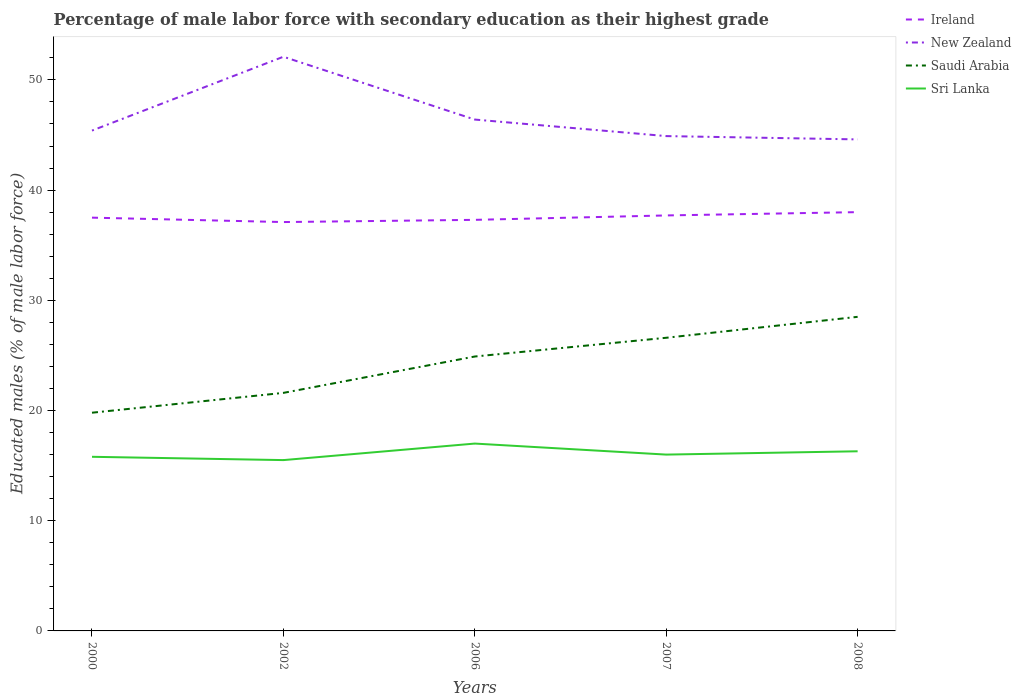How many different coloured lines are there?
Offer a very short reply. 4. Across all years, what is the maximum percentage of male labor force with secondary education in Saudi Arabia?
Give a very brief answer. 19.8. In which year was the percentage of male labor force with secondary education in Sri Lanka maximum?
Your response must be concise. 2002. What is the total percentage of male labor force with secondary education in Sri Lanka in the graph?
Give a very brief answer. 0.3. What is the difference between the highest and the second highest percentage of male labor force with secondary education in Ireland?
Offer a terse response. 0.9. How many lines are there?
Provide a short and direct response. 4. What is the difference between two consecutive major ticks on the Y-axis?
Ensure brevity in your answer.  10. Are the values on the major ticks of Y-axis written in scientific E-notation?
Provide a succinct answer. No. Does the graph contain any zero values?
Provide a short and direct response. No. What is the title of the graph?
Make the answer very short. Percentage of male labor force with secondary education as their highest grade. Does "Singapore" appear as one of the legend labels in the graph?
Ensure brevity in your answer.  No. What is the label or title of the Y-axis?
Provide a short and direct response. Educated males (% of male labor force). What is the Educated males (% of male labor force) in Ireland in 2000?
Make the answer very short. 37.5. What is the Educated males (% of male labor force) in New Zealand in 2000?
Your answer should be compact. 45.4. What is the Educated males (% of male labor force) in Saudi Arabia in 2000?
Provide a succinct answer. 19.8. What is the Educated males (% of male labor force) of Sri Lanka in 2000?
Your answer should be very brief. 15.8. What is the Educated males (% of male labor force) of Ireland in 2002?
Your response must be concise. 37.1. What is the Educated males (% of male labor force) of New Zealand in 2002?
Provide a succinct answer. 52.1. What is the Educated males (% of male labor force) in Saudi Arabia in 2002?
Ensure brevity in your answer.  21.6. What is the Educated males (% of male labor force) of Sri Lanka in 2002?
Your response must be concise. 15.5. What is the Educated males (% of male labor force) in Ireland in 2006?
Make the answer very short. 37.3. What is the Educated males (% of male labor force) in New Zealand in 2006?
Keep it short and to the point. 46.4. What is the Educated males (% of male labor force) in Saudi Arabia in 2006?
Offer a very short reply. 24.9. What is the Educated males (% of male labor force) of Ireland in 2007?
Provide a short and direct response. 37.7. What is the Educated males (% of male labor force) of New Zealand in 2007?
Offer a very short reply. 44.9. What is the Educated males (% of male labor force) of Saudi Arabia in 2007?
Give a very brief answer. 26.6. What is the Educated males (% of male labor force) in Sri Lanka in 2007?
Give a very brief answer. 16. What is the Educated males (% of male labor force) in New Zealand in 2008?
Keep it short and to the point. 44.6. What is the Educated males (% of male labor force) in Sri Lanka in 2008?
Keep it short and to the point. 16.3. Across all years, what is the maximum Educated males (% of male labor force) in New Zealand?
Ensure brevity in your answer.  52.1. Across all years, what is the maximum Educated males (% of male labor force) in Saudi Arabia?
Give a very brief answer. 28.5. Across all years, what is the maximum Educated males (% of male labor force) in Sri Lanka?
Your answer should be very brief. 17. Across all years, what is the minimum Educated males (% of male labor force) in Ireland?
Your answer should be very brief. 37.1. Across all years, what is the minimum Educated males (% of male labor force) of New Zealand?
Provide a succinct answer. 44.6. Across all years, what is the minimum Educated males (% of male labor force) of Saudi Arabia?
Keep it short and to the point. 19.8. What is the total Educated males (% of male labor force) in Ireland in the graph?
Provide a succinct answer. 187.6. What is the total Educated males (% of male labor force) of New Zealand in the graph?
Your response must be concise. 233.4. What is the total Educated males (% of male labor force) of Saudi Arabia in the graph?
Your answer should be very brief. 121.4. What is the total Educated males (% of male labor force) of Sri Lanka in the graph?
Offer a terse response. 80.6. What is the difference between the Educated males (% of male labor force) in Ireland in 2000 and that in 2002?
Offer a very short reply. 0.4. What is the difference between the Educated males (% of male labor force) of Sri Lanka in 2000 and that in 2002?
Make the answer very short. 0.3. What is the difference between the Educated males (% of male labor force) in New Zealand in 2000 and that in 2006?
Offer a terse response. -1. What is the difference between the Educated males (% of male labor force) in Sri Lanka in 2000 and that in 2007?
Provide a succinct answer. -0.2. What is the difference between the Educated males (% of male labor force) in Ireland in 2000 and that in 2008?
Provide a short and direct response. -0.5. What is the difference between the Educated males (% of male labor force) of New Zealand in 2000 and that in 2008?
Provide a succinct answer. 0.8. What is the difference between the Educated males (% of male labor force) of Sri Lanka in 2000 and that in 2008?
Your answer should be compact. -0.5. What is the difference between the Educated males (% of male labor force) in Ireland in 2002 and that in 2006?
Provide a short and direct response. -0.2. What is the difference between the Educated males (% of male labor force) in Saudi Arabia in 2002 and that in 2006?
Your answer should be compact. -3.3. What is the difference between the Educated males (% of male labor force) in Saudi Arabia in 2002 and that in 2007?
Offer a terse response. -5. What is the difference between the Educated males (% of male labor force) of Ireland in 2002 and that in 2008?
Provide a succinct answer. -0.9. What is the difference between the Educated males (% of male labor force) in Saudi Arabia in 2002 and that in 2008?
Make the answer very short. -6.9. What is the difference between the Educated males (% of male labor force) of Sri Lanka in 2002 and that in 2008?
Your response must be concise. -0.8. What is the difference between the Educated males (% of male labor force) in Saudi Arabia in 2006 and that in 2007?
Provide a succinct answer. -1.7. What is the difference between the Educated males (% of male labor force) of Sri Lanka in 2006 and that in 2007?
Your response must be concise. 1. What is the difference between the Educated males (% of male labor force) in Ireland in 2006 and that in 2008?
Keep it short and to the point. -0.7. What is the difference between the Educated males (% of male labor force) of New Zealand in 2006 and that in 2008?
Make the answer very short. 1.8. What is the difference between the Educated males (% of male labor force) in New Zealand in 2007 and that in 2008?
Your answer should be very brief. 0.3. What is the difference between the Educated males (% of male labor force) in Saudi Arabia in 2007 and that in 2008?
Your answer should be compact. -1.9. What is the difference between the Educated males (% of male labor force) in Ireland in 2000 and the Educated males (% of male labor force) in New Zealand in 2002?
Your response must be concise. -14.6. What is the difference between the Educated males (% of male labor force) of Ireland in 2000 and the Educated males (% of male labor force) of Saudi Arabia in 2002?
Provide a succinct answer. 15.9. What is the difference between the Educated males (% of male labor force) of Ireland in 2000 and the Educated males (% of male labor force) of Sri Lanka in 2002?
Provide a succinct answer. 22. What is the difference between the Educated males (% of male labor force) of New Zealand in 2000 and the Educated males (% of male labor force) of Saudi Arabia in 2002?
Offer a very short reply. 23.8. What is the difference between the Educated males (% of male labor force) of New Zealand in 2000 and the Educated males (% of male labor force) of Sri Lanka in 2002?
Make the answer very short. 29.9. What is the difference between the Educated males (% of male labor force) in Ireland in 2000 and the Educated males (% of male labor force) in Saudi Arabia in 2006?
Make the answer very short. 12.6. What is the difference between the Educated males (% of male labor force) of Ireland in 2000 and the Educated males (% of male labor force) of Sri Lanka in 2006?
Offer a terse response. 20.5. What is the difference between the Educated males (% of male labor force) of New Zealand in 2000 and the Educated males (% of male labor force) of Saudi Arabia in 2006?
Make the answer very short. 20.5. What is the difference between the Educated males (% of male labor force) of New Zealand in 2000 and the Educated males (% of male labor force) of Sri Lanka in 2006?
Ensure brevity in your answer.  28.4. What is the difference between the Educated males (% of male labor force) in New Zealand in 2000 and the Educated males (% of male labor force) in Saudi Arabia in 2007?
Your answer should be very brief. 18.8. What is the difference between the Educated males (% of male labor force) of New Zealand in 2000 and the Educated males (% of male labor force) of Sri Lanka in 2007?
Offer a very short reply. 29.4. What is the difference between the Educated males (% of male labor force) of Ireland in 2000 and the Educated males (% of male labor force) of New Zealand in 2008?
Make the answer very short. -7.1. What is the difference between the Educated males (% of male labor force) of Ireland in 2000 and the Educated males (% of male labor force) of Saudi Arabia in 2008?
Offer a very short reply. 9. What is the difference between the Educated males (% of male labor force) of Ireland in 2000 and the Educated males (% of male labor force) of Sri Lanka in 2008?
Offer a very short reply. 21.2. What is the difference between the Educated males (% of male labor force) of New Zealand in 2000 and the Educated males (% of male labor force) of Saudi Arabia in 2008?
Keep it short and to the point. 16.9. What is the difference between the Educated males (% of male labor force) of New Zealand in 2000 and the Educated males (% of male labor force) of Sri Lanka in 2008?
Your answer should be compact. 29.1. What is the difference between the Educated males (% of male labor force) in Ireland in 2002 and the Educated males (% of male labor force) in New Zealand in 2006?
Your answer should be very brief. -9.3. What is the difference between the Educated males (% of male labor force) of Ireland in 2002 and the Educated males (% of male labor force) of Saudi Arabia in 2006?
Ensure brevity in your answer.  12.2. What is the difference between the Educated males (% of male labor force) in Ireland in 2002 and the Educated males (% of male labor force) in Sri Lanka in 2006?
Give a very brief answer. 20.1. What is the difference between the Educated males (% of male labor force) in New Zealand in 2002 and the Educated males (% of male labor force) in Saudi Arabia in 2006?
Provide a short and direct response. 27.2. What is the difference between the Educated males (% of male labor force) in New Zealand in 2002 and the Educated males (% of male labor force) in Sri Lanka in 2006?
Offer a very short reply. 35.1. What is the difference between the Educated males (% of male labor force) of Saudi Arabia in 2002 and the Educated males (% of male labor force) of Sri Lanka in 2006?
Your answer should be compact. 4.6. What is the difference between the Educated males (% of male labor force) of Ireland in 2002 and the Educated males (% of male labor force) of Saudi Arabia in 2007?
Offer a terse response. 10.5. What is the difference between the Educated males (% of male labor force) of Ireland in 2002 and the Educated males (% of male labor force) of Sri Lanka in 2007?
Provide a succinct answer. 21.1. What is the difference between the Educated males (% of male labor force) in New Zealand in 2002 and the Educated males (% of male labor force) in Sri Lanka in 2007?
Provide a succinct answer. 36.1. What is the difference between the Educated males (% of male labor force) in Ireland in 2002 and the Educated males (% of male labor force) in New Zealand in 2008?
Your answer should be very brief. -7.5. What is the difference between the Educated males (% of male labor force) in Ireland in 2002 and the Educated males (% of male labor force) in Sri Lanka in 2008?
Provide a succinct answer. 20.8. What is the difference between the Educated males (% of male labor force) in New Zealand in 2002 and the Educated males (% of male labor force) in Saudi Arabia in 2008?
Offer a terse response. 23.6. What is the difference between the Educated males (% of male labor force) of New Zealand in 2002 and the Educated males (% of male labor force) of Sri Lanka in 2008?
Your answer should be compact. 35.8. What is the difference between the Educated males (% of male labor force) in Saudi Arabia in 2002 and the Educated males (% of male labor force) in Sri Lanka in 2008?
Your response must be concise. 5.3. What is the difference between the Educated males (% of male labor force) of Ireland in 2006 and the Educated males (% of male labor force) of Saudi Arabia in 2007?
Offer a very short reply. 10.7. What is the difference between the Educated males (% of male labor force) in Ireland in 2006 and the Educated males (% of male labor force) in Sri Lanka in 2007?
Provide a succinct answer. 21.3. What is the difference between the Educated males (% of male labor force) in New Zealand in 2006 and the Educated males (% of male labor force) in Saudi Arabia in 2007?
Keep it short and to the point. 19.8. What is the difference between the Educated males (% of male labor force) of New Zealand in 2006 and the Educated males (% of male labor force) of Sri Lanka in 2007?
Ensure brevity in your answer.  30.4. What is the difference between the Educated males (% of male labor force) of Ireland in 2006 and the Educated males (% of male labor force) of New Zealand in 2008?
Make the answer very short. -7.3. What is the difference between the Educated males (% of male labor force) in Ireland in 2006 and the Educated males (% of male labor force) in Saudi Arabia in 2008?
Provide a short and direct response. 8.8. What is the difference between the Educated males (% of male labor force) in New Zealand in 2006 and the Educated males (% of male labor force) in Sri Lanka in 2008?
Offer a very short reply. 30.1. What is the difference between the Educated males (% of male labor force) in Saudi Arabia in 2006 and the Educated males (% of male labor force) in Sri Lanka in 2008?
Offer a very short reply. 8.6. What is the difference between the Educated males (% of male labor force) of Ireland in 2007 and the Educated males (% of male labor force) of New Zealand in 2008?
Your response must be concise. -6.9. What is the difference between the Educated males (% of male labor force) in Ireland in 2007 and the Educated males (% of male labor force) in Saudi Arabia in 2008?
Provide a short and direct response. 9.2. What is the difference between the Educated males (% of male labor force) of Ireland in 2007 and the Educated males (% of male labor force) of Sri Lanka in 2008?
Provide a succinct answer. 21.4. What is the difference between the Educated males (% of male labor force) in New Zealand in 2007 and the Educated males (% of male labor force) in Sri Lanka in 2008?
Keep it short and to the point. 28.6. What is the difference between the Educated males (% of male labor force) of Saudi Arabia in 2007 and the Educated males (% of male labor force) of Sri Lanka in 2008?
Provide a short and direct response. 10.3. What is the average Educated males (% of male labor force) of Ireland per year?
Make the answer very short. 37.52. What is the average Educated males (% of male labor force) in New Zealand per year?
Your answer should be very brief. 46.68. What is the average Educated males (% of male labor force) of Saudi Arabia per year?
Keep it short and to the point. 24.28. What is the average Educated males (% of male labor force) in Sri Lanka per year?
Offer a very short reply. 16.12. In the year 2000, what is the difference between the Educated males (% of male labor force) in Ireland and Educated males (% of male labor force) in New Zealand?
Ensure brevity in your answer.  -7.9. In the year 2000, what is the difference between the Educated males (% of male labor force) of Ireland and Educated males (% of male labor force) of Saudi Arabia?
Offer a very short reply. 17.7. In the year 2000, what is the difference between the Educated males (% of male labor force) of Ireland and Educated males (% of male labor force) of Sri Lanka?
Give a very brief answer. 21.7. In the year 2000, what is the difference between the Educated males (% of male labor force) of New Zealand and Educated males (% of male labor force) of Saudi Arabia?
Your answer should be compact. 25.6. In the year 2000, what is the difference between the Educated males (% of male labor force) of New Zealand and Educated males (% of male labor force) of Sri Lanka?
Provide a succinct answer. 29.6. In the year 2000, what is the difference between the Educated males (% of male labor force) in Saudi Arabia and Educated males (% of male labor force) in Sri Lanka?
Your answer should be compact. 4. In the year 2002, what is the difference between the Educated males (% of male labor force) of Ireland and Educated males (% of male labor force) of New Zealand?
Offer a terse response. -15. In the year 2002, what is the difference between the Educated males (% of male labor force) in Ireland and Educated males (% of male labor force) in Saudi Arabia?
Provide a succinct answer. 15.5. In the year 2002, what is the difference between the Educated males (% of male labor force) in Ireland and Educated males (% of male labor force) in Sri Lanka?
Make the answer very short. 21.6. In the year 2002, what is the difference between the Educated males (% of male labor force) in New Zealand and Educated males (% of male labor force) in Saudi Arabia?
Your answer should be very brief. 30.5. In the year 2002, what is the difference between the Educated males (% of male labor force) in New Zealand and Educated males (% of male labor force) in Sri Lanka?
Your response must be concise. 36.6. In the year 2002, what is the difference between the Educated males (% of male labor force) of Saudi Arabia and Educated males (% of male labor force) of Sri Lanka?
Your answer should be compact. 6.1. In the year 2006, what is the difference between the Educated males (% of male labor force) of Ireland and Educated males (% of male labor force) of New Zealand?
Offer a terse response. -9.1. In the year 2006, what is the difference between the Educated males (% of male labor force) of Ireland and Educated males (% of male labor force) of Sri Lanka?
Your answer should be compact. 20.3. In the year 2006, what is the difference between the Educated males (% of male labor force) of New Zealand and Educated males (% of male labor force) of Sri Lanka?
Keep it short and to the point. 29.4. In the year 2006, what is the difference between the Educated males (% of male labor force) of Saudi Arabia and Educated males (% of male labor force) of Sri Lanka?
Offer a very short reply. 7.9. In the year 2007, what is the difference between the Educated males (% of male labor force) of Ireland and Educated males (% of male labor force) of Sri Lanka?
Offer a very short reply. 21.7. In the year 2007, what is the difference between the Educated males (% of male labor force) of New Zealand and Educated males (% of male labor force) of Saudi Arabia?
Keep it short and to the point. 18.3. In the year 2007, what is the difference between the Educated males (% of male labor force) of New Zealand and Educated males (% of male labor force) of Sri Lanka?
Provide a succinct answer. 28.9. In the year 2007, what is the difference between the Educated males (% of male labor force) of Saudi Arabia and Educated males (% of male labor force) of Sri Lanka?
Your answer should be very brief. 10.6. In the year 2008, what is the difference between the Educated males (% of male labor force) in Ireland and Educated males (% of male labor force) in Saudi Arabia?
Give a very brief answer. 9.5. In the year 2008, what is the difference between the Educated males (% of male labor force) of Ireland and Educated males (% of male labor force) of Sri Lanka?
Your response must be concise. 21.7. In the year 2008, what is the difference between the Educated males (% of male labor force) of New Zealand and Educated males (% of male labor force) of Sri Lanka?
Your response must be concise. 28.3. What is the ratio of the Educated males (% of male labor force) of Ireland in 2000 to that in 2002?
Make the answer very short. 1.01. What is the ratio of the Educated males (% of male labor force) in New Zealand in 2000 to that in 2002?
Your response must be concise. 0.87. What is the ratio of the Educated males (% of male labor force) in Saudi Arabia in 2000 to that in 2002?
Make the answer very short. 0.92. What is the ratio of the Educated males (% of male labor force) in Sri Lanka in 2000 to that in 2002?
Make the answer very short. 1.02. What is the ratio of the Educated males (% of male labor force) in Ireland in 2000 to that in 2006?
Your answer should be very brief. 1.01. What is the ratio of the Educated males (% of male labor force) in New Zealand in 2000 to that in 2006?
Your answer should be very brief. 0.98. What is the ratio of the Educated males (% of male labor force) in Saudi Arabia in 2000 to that in 2006?
Ensure brevity in your answer.  0.8. What is the ratio of the Educated males (% of male labor force) in Sri Lanka in 2000 to that in 2006?
Ensure brevity in your answer.  0.93. What is the ratio of the Educated males (% of male labor force) of New Zealand in 2000 to that in 2007?
Give a very brief answer. 1.01. What is the ratio of the Educated males (% of male labor force) in Saudi Arabia in 2000 to that in 2007?
Your answer should be compact. 0.74. What is the ratio of the Educated males (% of male labor force) in Sri Lanka in 2000 to that in 2007?
Provide a short and direct response. 0.99. What is the ratio of the Educated males (% of male labor force) of Ireland in 2000 to that in 2008?
Your answer should be very brief. 0.99. What is the ratio of the Educated males (% of male labor force) in New Zealand in 2000 to that in 2008?
Provide a succinct answer. 1.02. What is the ratio of the Educated males (% of male labor force) of Saudi Arabia in 2000 to that in 2008?
Your response must be concise. 0.69. What is the ratio of the Educated males (% of male labor force) of Sri Lanka in 2000 to that in 2008?
Your answer should be compact. 0.97. What is the ratio of the Educated males (% of male labor force) of New Zealand in 2002 to that in 2006?
Your answer should be very brief. 1.12. What is the ratio of the Educated males (% of male labor force) of Saudi Arabia in 2002 to that in 2006?
Make the answer very short. 0.87. What is the ratio of the Educated males (% of male labor force) of Sri Lanka in 2002 to that in 2006?
Offer a terse response. 0.91. What is the ratio of the Educated males (% of male labor force) in Ireland in 2002 to that in 2007?
Offer a terse response. 0.98. What is the ratio of the Educated males (% of male labor force) in New Zealand in 2002 to that in 2007?
Offer a terse response. 1.16. What is the ratio of the Educated males (% of male labor force) in Saudi Arabia in 2002 to that in 2007?
Offer a very short reply. 0.81. What is the ratio of the Educated males (% of male labor force) of Sri Lanka in 2002 to that in 2007?
Provide a short and direct response. 0.97. What is the ratio of the Educated males (% of male labor force) of Ireland in 2002 to that in 2008?
Your answer should be very brief. 0.98. What is the ratio of the Educated males (% of male labor force) in New Zealand in 2002 to that in 2008?
Ensure brevity in your answer.  1.17. What is the ratio of the Educated males (% of male labor force) of Saudi Arabia in 2002 to that in 2008?
Offer a very short reply. 0.76. What is the ratio of the Educated males (% of male labor force) of Sri Lanka in 2002 to that in 2008?
Your answer should be compact. 0.95. What is the ratio of the Educated males (% of male labor force) of Ireland in 2006 to that in 2007?
Offer a terse response. 0.99. What is the ratio of the Educated males (% of male labor force) in New Zealand in 2006 to that in 2007?
Offer a terse response. 1.03. What is the ratio of the Educated males (% of male labor force) of Saudi Arabia in 2006 to that in 2007?
Keep it short and to the point. 0.94. What is the ratio of the Educated males (% of male labor force) in Ireland in 2006 to that in 2008?
Ensure brevity in your answer.  0.98. What is the ratio of the Educated males (% of male labor force) of New Zealand in 2006 to that in 2008?
Your answer should be very brief. 1.04. What is the ratio of the Educated males (% of male labor force) of Saudi Arabia in 2006 to that in 2008?
Offer a terse response. 0.87. What is the ratio of the Educated males (% of male labor force) in Sri Lanka in 2006 to that in 2008?
Your answer should be very brief. 1.04. What is the ratio of the Educated males (% of male labor force) of Sri Lanka in 2007 to that in 2008?
Provide a succinct answer. 0.98. What is the difference between the highest and the second highest Educated males (% of male labor force) of Sri Lanka?
Make the answer very short. 0.7. What is the difference between the highest and the lowest Educated males (% of male labor force) in Ireland?
Provide a short and direct response. 0.9. What is the difference between the highest and the lowest Educated males (% of male labor force) in New Zealand?
Your answer should be very brief. 7.5. 